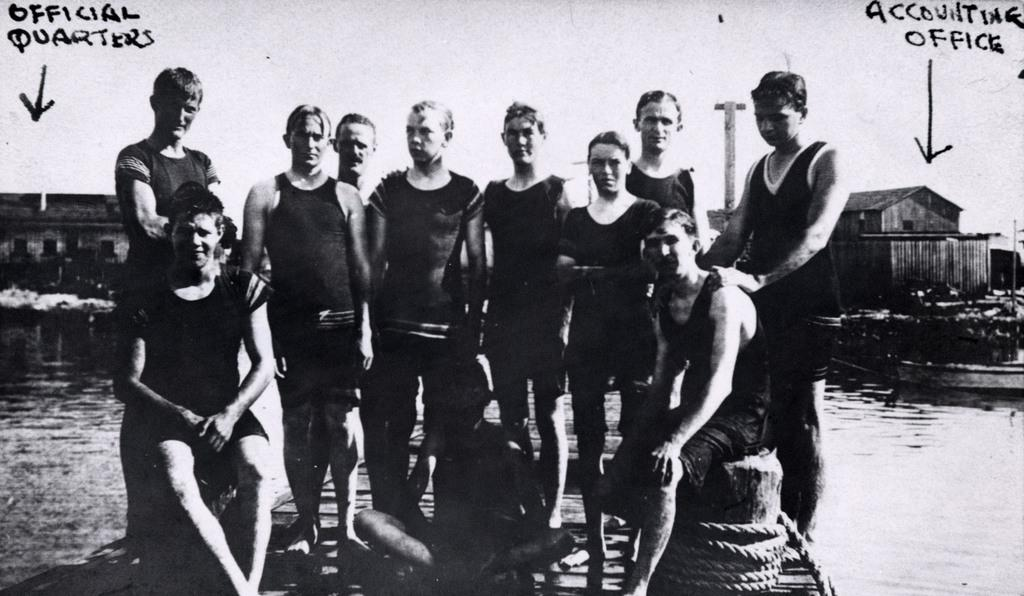What are the people in the image doing? The persons in the front of the image are standing and sitting. What can be seen in the background of the image? There is water and houses visible in the background of the image. Is there any text present in the image? Yes, there is some text written on the image. How many balls can be seen in the image? There are no balls visible in the image. Are there any children playing in the image? The provided facts do not mention any children in the image. 